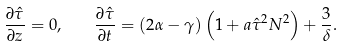Convert formula to latex. <formula><loc_0><loc_0><loc_500><loc_500>\frac { \partial \hat { \tau } } { \partial z } = 0 , \quad \frac { \partial \hat { \tau } } { \partial t } = ( 2 \alpha - \gamma ) \left ( 1 + a \hat { \tau } ^ { 2 } N ^ { 2 } \right ) + \frac { 3 } { \delta } .</formula> 